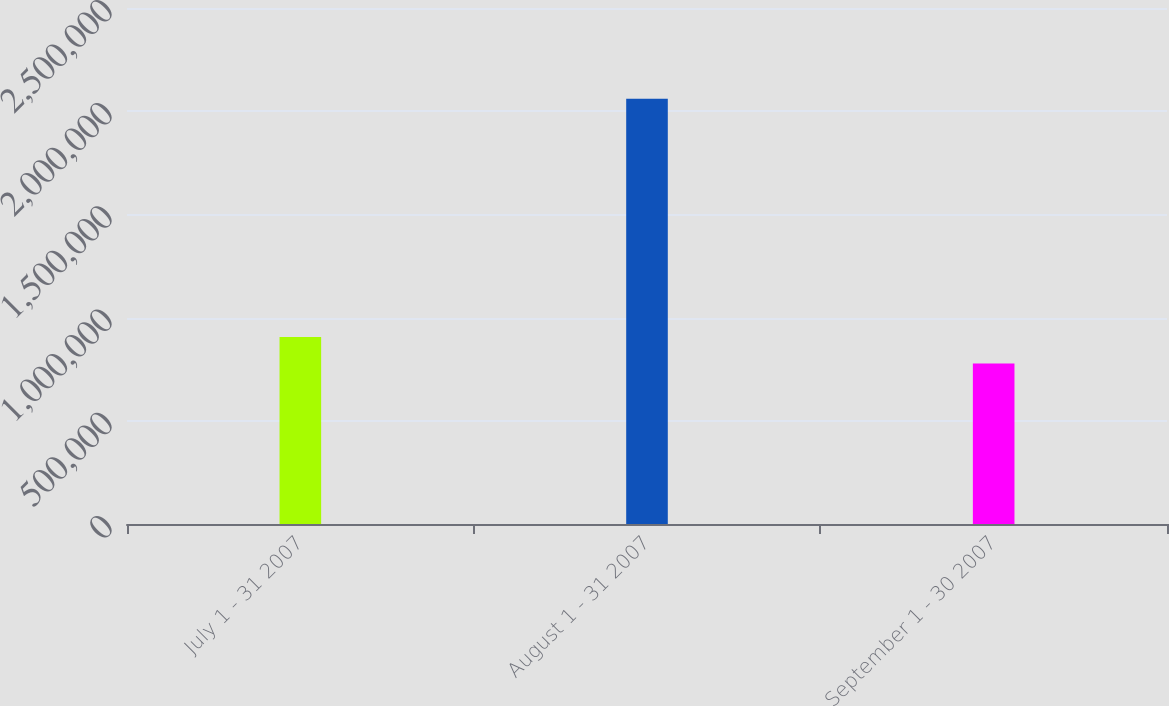<chart> <loc_0><loc_0><loc_500><loc_500><bar_chart><fcel>July 1 - 31 2007<fcel>August 1 - 31 2007<fcel>September 1 - 30 2007<nl><fcel>906204<fcel>2.0606e+06<fcel>777938<nl></chart> 